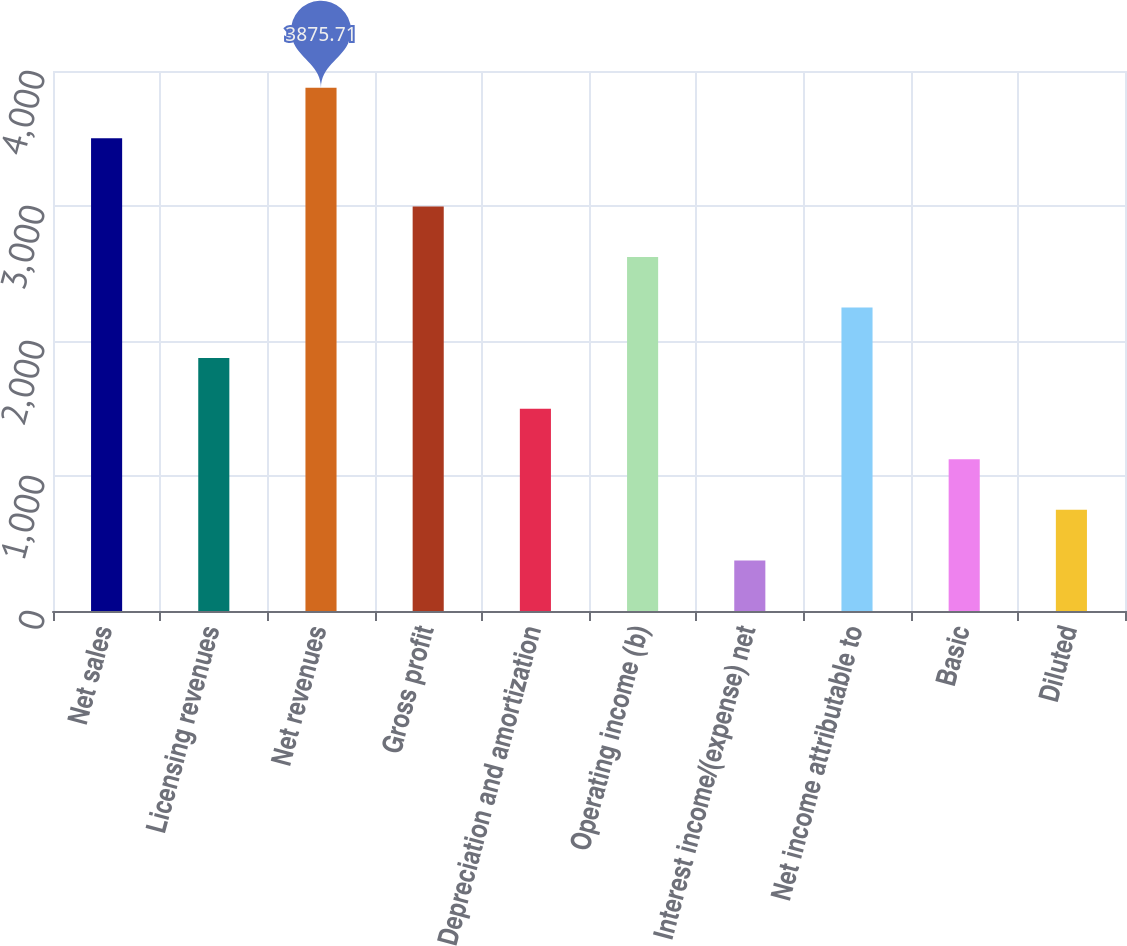<chart> <loc_0><loc_0><loc_500><loc_500><bar_chart><fcel>Net sales<fcel>Licensing revenues<fcel>Net revenues<fcel>Gross profit<fcel>Depreciation and amortization<fcel>Operating income (b)<fcel>Interest income/(expense) net<fcel>Net income attributable to<fcel>Basic<fcel>Diluted<nl><fcel>3501.1<fcel>1873.25<fcel>3875.71<fcel>2997.08<fcel>1498.64<fcel>2622.47<fcel>374.81<fcel>2247.86<fcel>1124.03<fcel>749.42<nl></chart> 